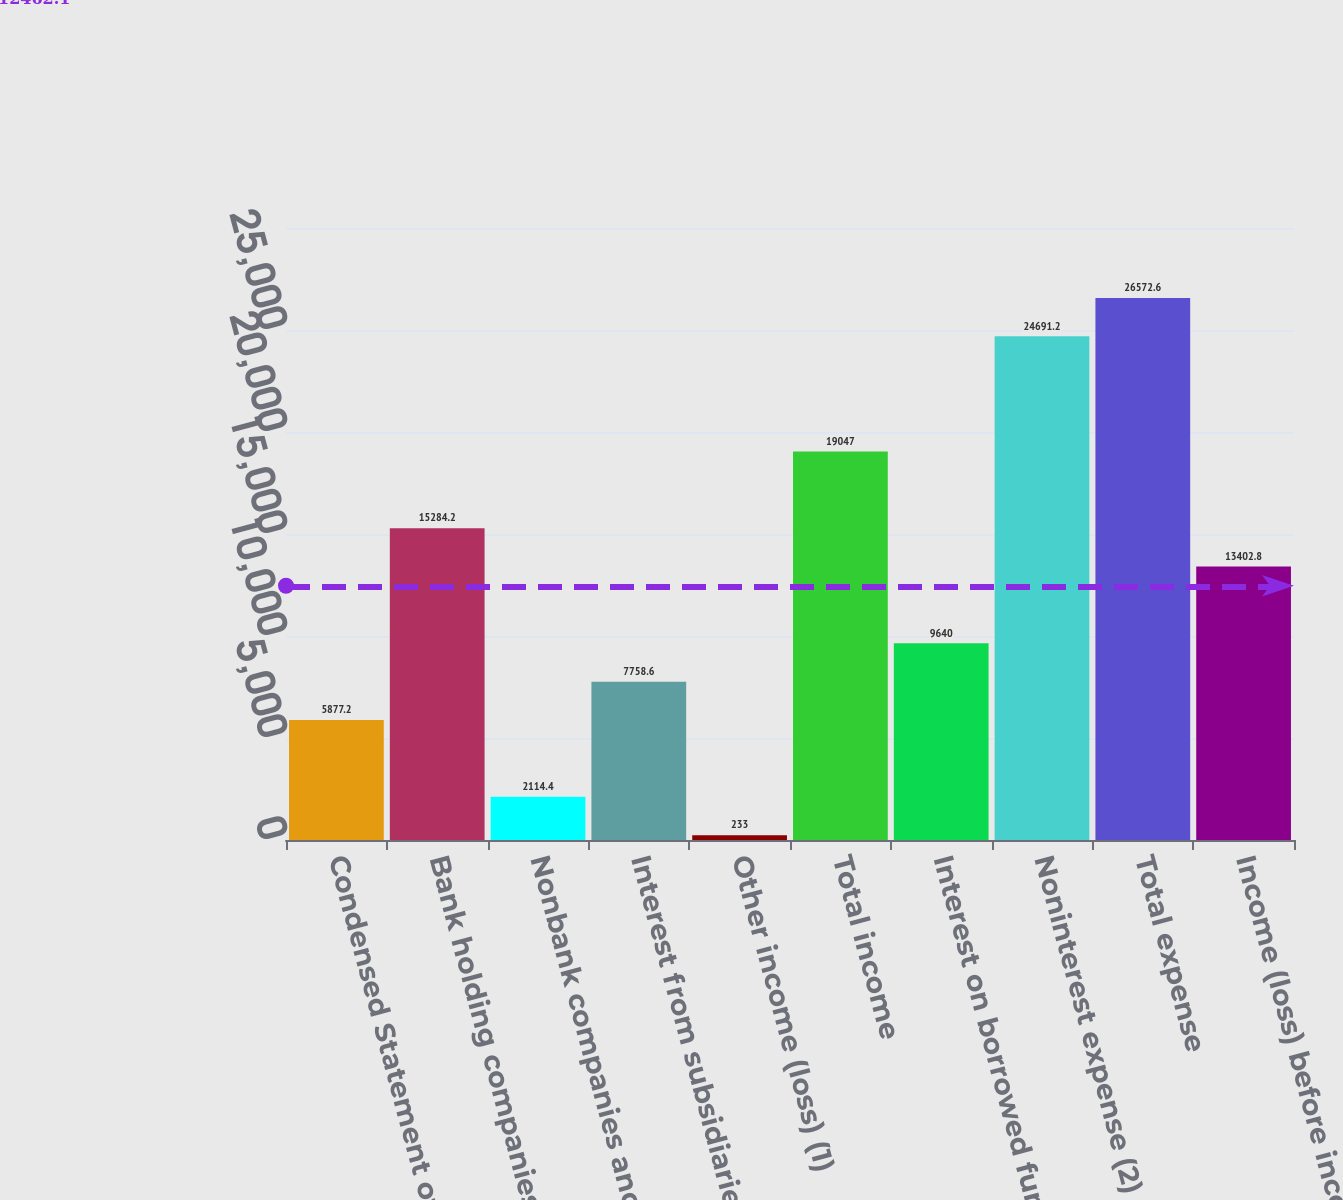Convert chart. <chart><loc_0><loc_0><loc_500><loc_500><bar_chart><fcel>Condensed Statement of Income<fcel>Bank holding companies and<fcel>Nonbank companies and related<fcel>Interest from subsidiaries<fcel>Other income (loss) (1)<fcel>Total income<fcel>Interest on borrowed funds<fcel>Noninterest expense (2)<fcel>Total expense<fcel>Income (loss) before income<nl><fcel>5877.2<fcel>15284.2<fcel>2114.4<fcel>7758.6<fcel>233<fcel>19047<fcel>9640<fcel>24691.2<fcel>26572.6<fcel>13402.8<nl></chart> 